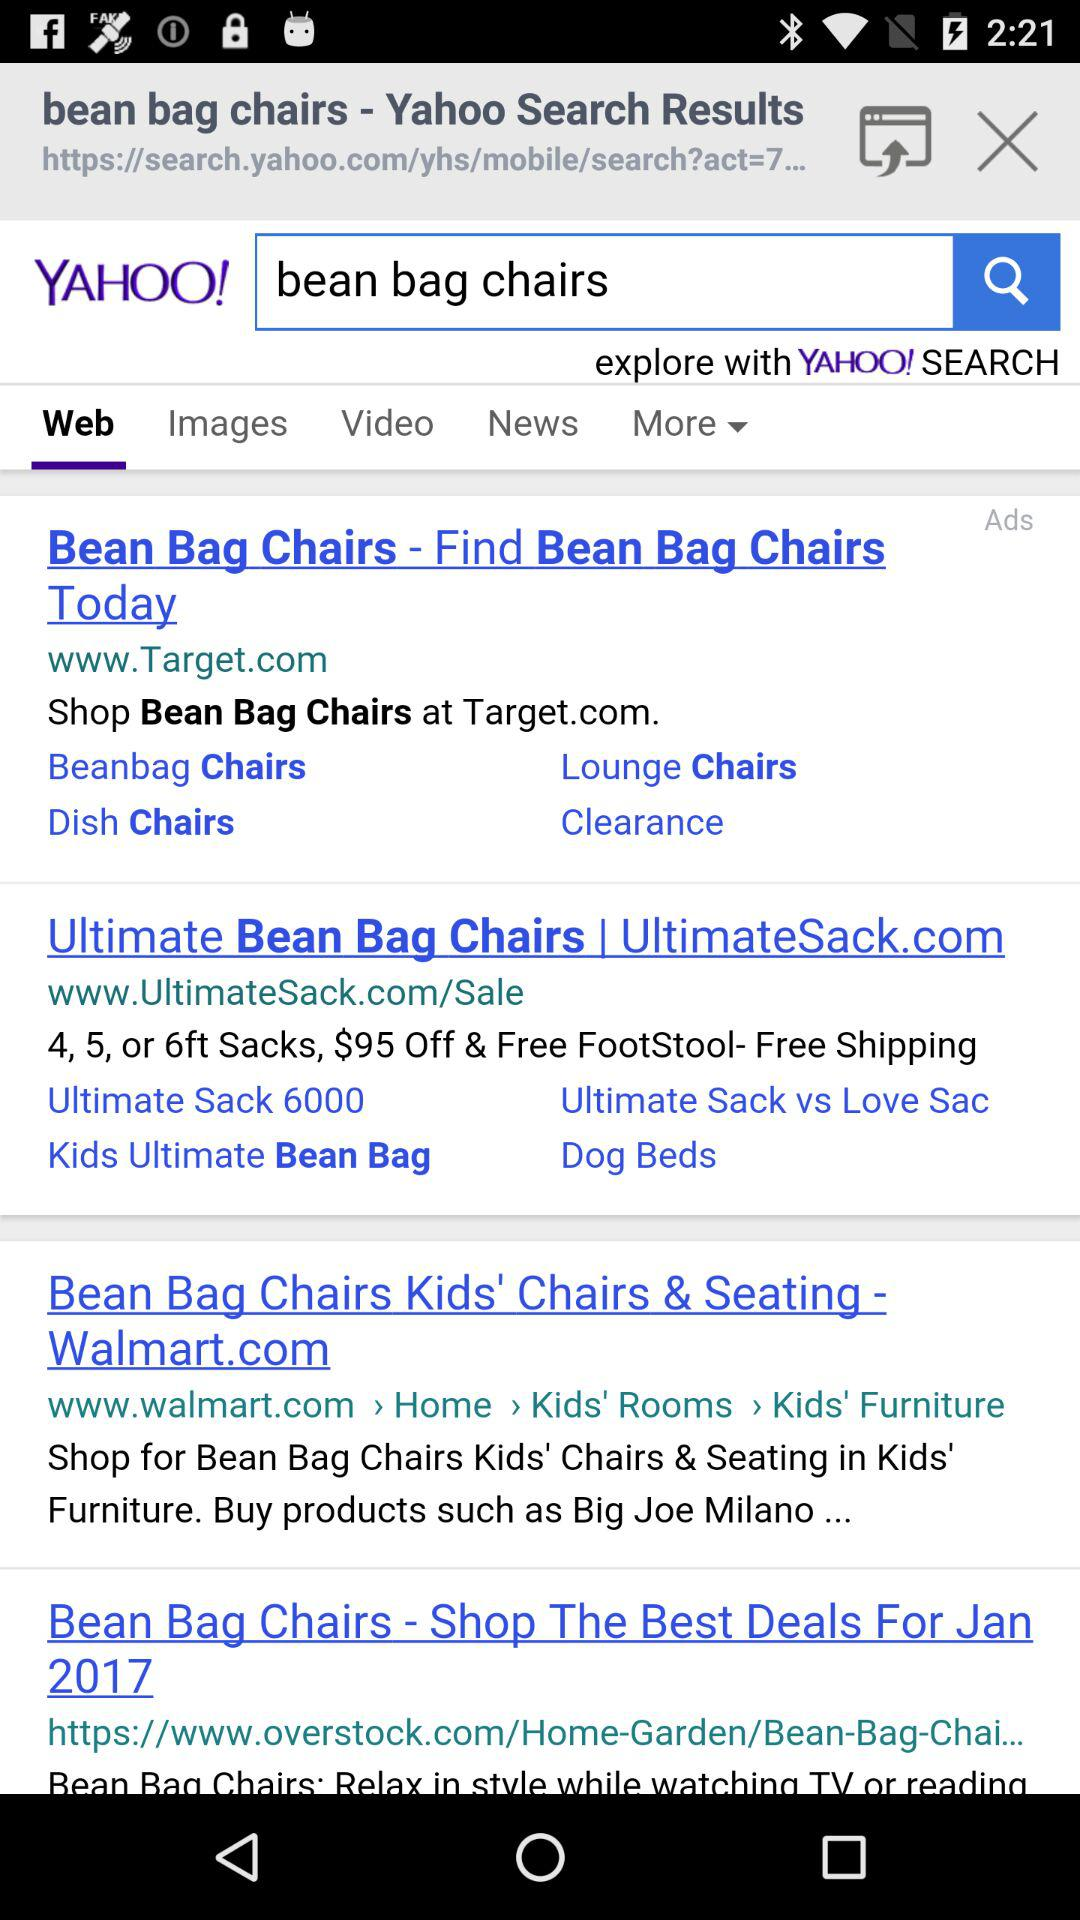How much of the amount is off on the "Bean Bag Chairs"? The amount is $95 off on the "Bean Bag Chairs". 